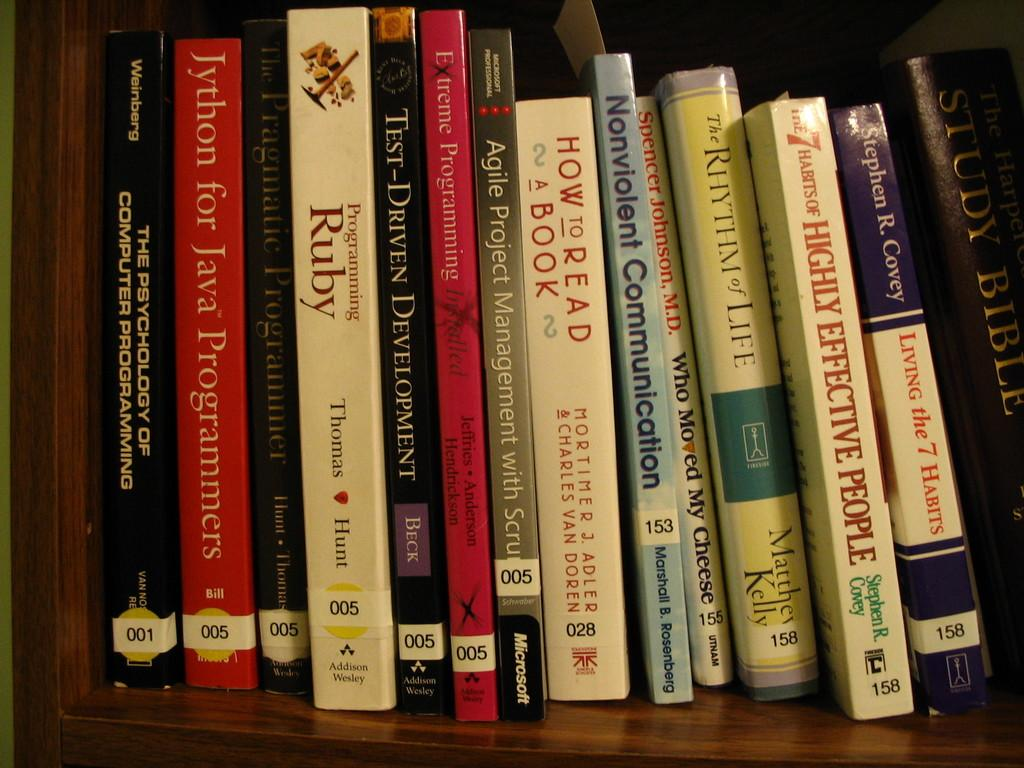<image>
Offer a succinct explanation of the picture presented. A group of self help books on a shelf at a library or store which have numbered labels at the bottoms. 